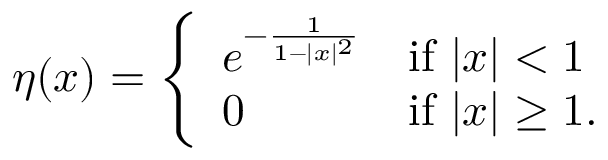<formula> <loc_0><loc_0><loc_500><loc_500>\eta ( x ) = { \left \{ \begin{array} { l l } { e ^ { - { \frac { 1 } { 1 - | x | ^ { 2 } } } } } & { { i f } | x | < 1 } \\ { 0 } & { { i f } | x | \geq 1 . } \end{array} }</formula> 